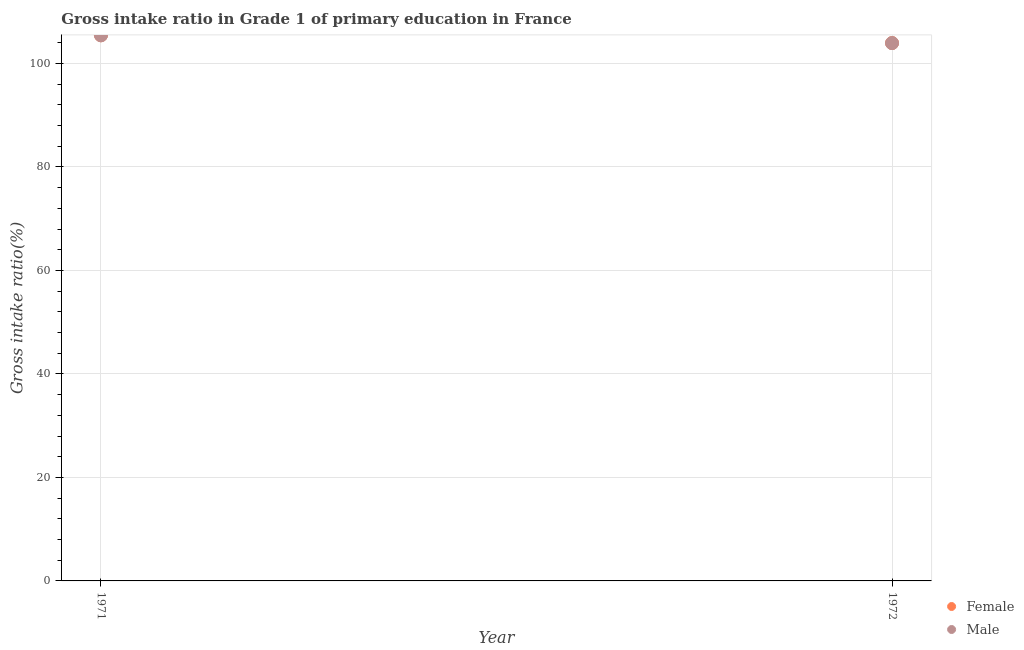How many different coloured dotlines are there?
Your answer should be very brief. 2. What is the gross intake ratio(female) in 1972?
Ensure brevity in your answer.  103.94. Across all years, what is the maximum gross intake ratio(male)?
Provide a short and direct response. 105.43. Across all years, what is the minimum gross intake ratio(female)?
Provide a short and direct response. 103.94. What is the total gross intake ratio(male) in the graph?
Provide a succinct answer. 209.37. What is the difference between the gross intake ratio(female) in 1971 and that in 1972?
Offer a terse response. 1.51. What is the difference between the gross intake ratio(female) in 1972 and the gross intake ratio(male) in 1971?
Give a very brief answer. -1.49. What is the average gross intake ratio(male) per year?
Provide a succinct answer. 104.69. In the year 1972, what is the difference between the gross intake ratio(male) and gross intake ratio(female)?
Offer a very short reply. -0.01. What is the ratio of the gross intake ratio(female) in 1971 to that in 1972?
Make the answer very short. 1.01. Does the gross intake ratio(male) monotonically increase over the years?
Your answer should be very brief. No. Is the gross intake ratio(female) strictly greater than the gross intake ratio(male) over the years?
Your answer should be very brief. Yes. Is the gross intake ratio(male) strictly less than the gross intake ratio(female) over the years?
Give a very brief answer. Yes. How many dotlines are there?
Offer a very short reply. 2. Does the graph contain any zero values?
Ensure brevity in your answer.  No. How many legend labels are there?
Keep it short and to the point. 2. What is the title of the graph?
Provide a succinct answer. Gross intake ratio in Grade 1 of primary education in France. Does "Adolescent fertility rate" appear as one of the legend labels in the graph?
Offer a very short reply. No. What is the label or title of the X-axis?
Your answer should be compact. Year. What is the label or title of the Y-axis?
Make the answer very short. Gross intake ratio(%). What is the Gross intake ratio(%) in Female in 1971?
Make the answer very short. 105.45. What is the Gross intake ratio(%) in Male in 1971?
Provide a succinct answer. 105.43. What is the Gross intake ratio(%) in Female in 1972?
Offer a terse response. 103.94. What is the Gross intake ratio(%) of Male in 1972?
Provide a short and direct response. 103.94. Across all years, what is the maximum Gross intake ratio(%) of Female?
Make the answer very short. 105.45. Across all years, what is the maximum Gross intake ratio(%) in Male?
Provide a short and direct response. 105.43. Across all years, what is the minimum Gross intake ratio(%) of Female?
Provide a short and direct response. 103.94. Across all years, what is the minimum Gross intake ratio(%) in Male?
Provide a short and direct response. 103.94. What is the total Gross intake ratio(%) of Female in the graph?
Provide a succinct answer. 209.4. What is the total Gross intake ratio(%) of Male in the graph?
Your response must be concise. 209.37. What is the difference between the Gross intake ratio(%) in Female in 1971 and that in 1972?
Your answer should be very brief. 1.51. What is the difference between the Gross intake ratio(%) in Male in 1971 and that in 1972?
Keep it short and to the point. 1.49. What is the difference between the Gross intake ratio(%) in Female in 1971 and the Gross intake ratio(%) in Male in 1972?
Offer a very short reply. 1.51. What is the average Gross intake ratio(%) of Female per year?
Ensure brevity in your answer.  104.7. What is the average Gross intake ratio(%) in Male per year?
Make the answer very short. 104.69. In the year 1971, what is the difference between the Gross intake ratio(%) in Female and Gross intake ratio(%) in Male?
Provide a short and direct response. 0.02. In the year 1972, what is the difference between the Gross intake ratio(%) in Female and Gross intake ratio(%) in Male?
Give a very brief answer. 0.01. What is the ratio of the Gross intake ratio(%) of Female in 1971 to that in 1972?
Ensure brevity in your answer.  1.01. What is the ratio of the Gross intake ratio(%) of Male in 1971 to that in 1972?
Offer a very short reply. 1.01. What is the difference between the highest and the second highest Gross intake ratio(%) in Female?
Provide a succinct answer. 1.51. What is the difference between the highest and the second highest Gross intake ratio(%) in Male?
Your answer should be compact. 1.49. What is the difference between the highest and the lowest Gross intake ratio(%) of Female?
Offer a terse response. 1.51. What is the difference between the highest and the lowest Gross intake ratio(%) of Male?
Your answer should be very brief. 1.49. 